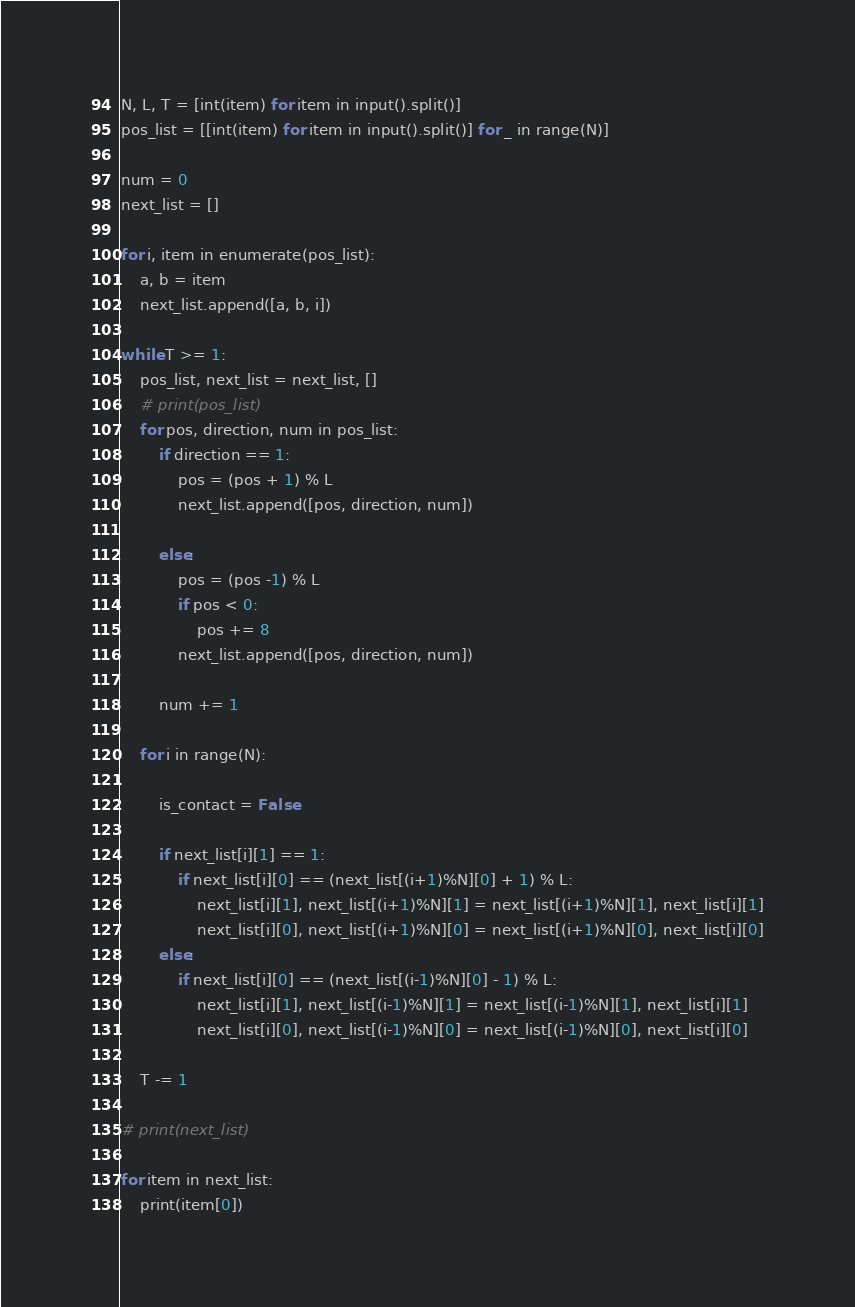Convert code to text. <code><loc_0><loc_0><loc_500><loc_500><_Python_>N, L, T = [int(item) for item in input().split()]
pos_list = [[int(item) for item in input().split()] for _ in range(N)]

num = 0
next_list = []

for i, item in enumerate(pos_list):
    a, b = item
    next_list.append([a, b, i])

while T >= 1:
    pos_list, next_list = next_list, []
    # print(pos_list)
    for pos, direction, num in pos_list:
        if direction == 1:
            pos = (pos + 1) % L
            next_list.append([pos, direction, num])

        else:
            pos = (pos -1) % L
            if pos < 0:
                pos += 8
            next_list.append([pos, direction, num])
        
        num += 1

    for i in range(N):
        
        is_contact = False

        if next_list[i][1] == 1:
            if next_list[i][0] == (next_list[(i+1)%N][0] + 1) % L:
                next_list[i][1], next_list[(i+1)%N][1] = next_list[(i+1)%N][1], next_list[i][1]
                next_list[i][0], next_list[(i+1)%N][0] = next_list[(i+1)%N][0], next_list[i][0]
        else:
            if next_list[i][0] == (next_list[(i-1)%N][0] - 1) % L:
                next_list[i][1], next_list[(i-1)%N][1] = next_list[(i-1)%N][1], next_list[i][1]
                next_list[i][0], next_list[(i-1)%N][0] = next_list[(i-1)%N][0], next_list[i][0]

    T -= 1

# print(next_list)

for item in next_list:
    print(item[0])
</code> 